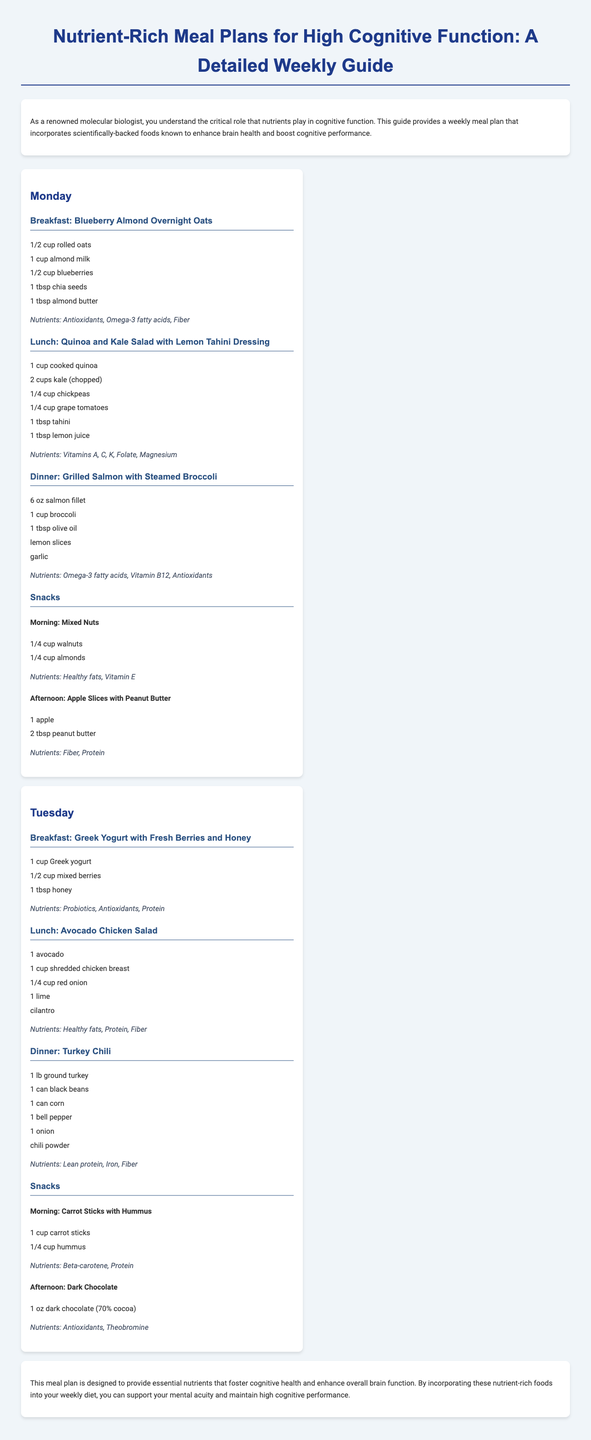What is the title of the meal plan? The title of the meal plan is displayed prominently at the top of the document.
Answer: Nutrient-Rich Meal Plans for High Cognitive Function: A Detailed Weekly Guide What meal is suggested for breakfast on Monday? The document lists breakfast options under each day, specifically mentioning the meal for Monday.
Answer: Blueberry Almond Overnight Oats How many ounces of salmon are in Monday's dinner? The dinner section specifies the portion size for salmon in Monday's meal plan.
Answer: 6 oz Which nutrient is emphasized for Greek Yogurt with Fresh Berries and Honey? Each meal includes a nutrients section that describes the nutrients for that specific meal.
Answer: Probiotics What is the afternoon snack choice on Tuesday? The snack section for Tuesday lists the specific afternoon snack.
Answer: Dark Chocolate How many cups of kale are used in Tuesday's lunch? The lunch meal on Tuesday specifies the quantity of kale included in the recipe.
Answer: 2 cups Which nutrient is listed for the Mixed Nuts snack? The nutrients are outlined for each snack in the meal plan, detailing specific health benefits.
Answer: Healthy fats, Vitamin E What general effect does the meal plan aim to achieve? The conclusion summarizes the overarching goal of the meal plan based on the nutrients included.
Answer: Enhance overall brain function 